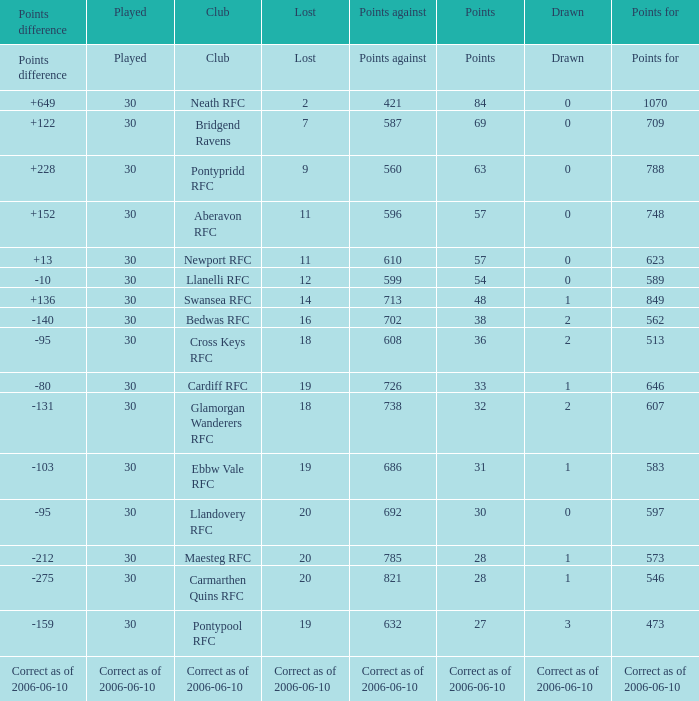What is Points, when Points For is "562"? 38.0. 